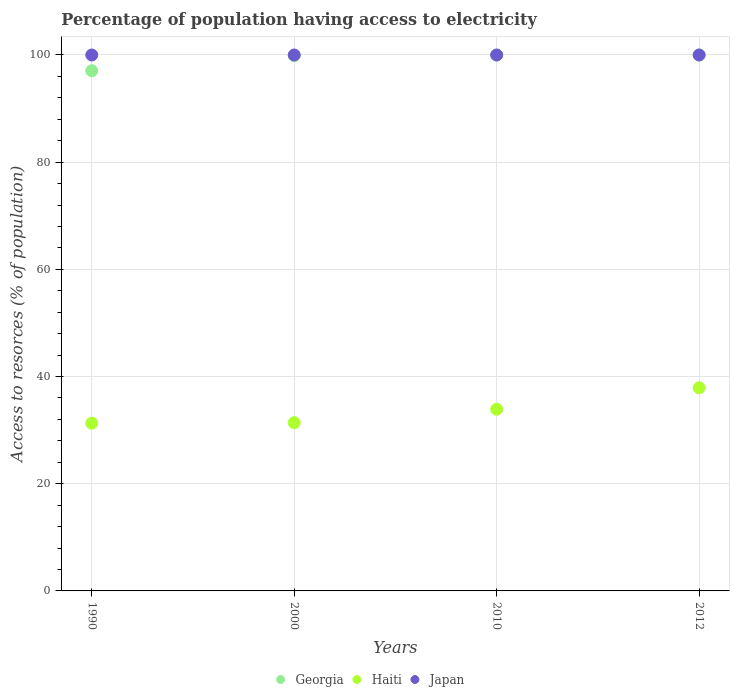How many different coloured dotlines are there?
Keep it short and to the point. 3. Is the number of dotlines equal to the number of legend labels?
Provide a succinct answer. Yes. What is the percentage of population having access to electricity in Georgia in 2010?
Offer a very short reply. 100. Across all years, what is the maximum percentage of population having access to electricity in Haiti?
Keep it short and to the point. 37.9. Across all years, what is the minimum percentage of population having access to electricity in Japan?
Offer a terse response. 100. In which year was the percentage of population having access to electricity in Japan maximum?
Offer a terse response. 1990. In which year was the percentage of population having access to electricity in Georgia minimum?
Make the answer very short. 1990. What is the total percentage of population having access to electricity in Japan in the graph?
Your answer should be very brief. 400. What is the difference between the percentage of population having access to electricity in Georgia in 2000 and that in 2012?
Offer a very short reply. -0.1. What is the difference between the percentage of population having access to electricity in Haiti in 1990 and the percentage of population having access to electricity in Japan in 2012?
Make the answer very short. -68.7. What is the average percentage of population having access to electricity in Georgia per year?
Your answer should be very brief. 99.24. In the year 2010, what is the difference between the percentage of population having access to electricity in Japan and percentage of population having access to electricity in Georgia?
Your response must be concise. 0. In how many years, is the percentage of population having access to electricity in Haiti greater than 8 %?
Your answer should be compact. 4. What is the ratio of the percentage of population having access to electricity in Haiti in 1990 to that in 2000?
Offer a very short reply. 1. Is the difference between the percentage of population having access to electricity in Japan in 1990 and 2012 greater than the difference between the percentage of population having access to electricity in Georgia in 1990 and 2012?
Give a very brief answer. Yes. What is the difference between the highest and the lowest percentage of population having access to electricity in Georgia?
Your answer should be very brief. 2.94. Is the sum of the percentage of population having access to electricity in Georgia in 1990 and 2000 greater than the maximum percentage of population having access to electricity in Japan across all years?
Give a very brief answer. Yes. Does the percentage of population having access to electricity in Japan monotonically increase over the years?
Provide a short and direct response. No. Is the percentage of population having access to electricity in Haiti strictly less than the percentage of population having access to electricity in Georgia over the years?
Make the answer very short. Yes. How many dotlines are there?
Your answer should be very brief. 3. How many years are there in the graph?
Offer a terse response. 4. What is the difference between two consecutive major ticks on the Y-axis?
Your answer should be very brief. 20. Are the values on the major ticks of Y-axis written in scientific E-notation?
Keep it short and to the point. No. Does the graph contain any zero values?
Make the answer very short. No. Does the graph contain grids?
Make the answer very short. Yes. How many legend labels are there?
Provide a short and direct response. 3. What is the title of the graph?
Provide a succinct answer. Percentage of population having access to electricity. What is the label or title of the X-axis?
Keep it short and to the point. Years. What is the label or title of the Y-axis?
Give a very brief answer. Access to resorces (% of population). What is the Access to resorces (% of population) of Georgia in 1990?
Your response must be concise. 97.06. What is the Access to resorces (% of population) of Haiti in 1990?
Ensure brevity in your answer.  31.3. What is the Access to resorces (% of population) in Japan in 1990?
Offer a terse response. 100. What is the Access to resorces (% of population) of Georgia in 2000?
Offer a very short reply. 99.9. What is the Access to resorces (% of population) of Haiti in 2000?
Your answer should be very brief. 31.4. What is the Access to resorces (% of population) of Georgia in 2010?
Offer a very short reply. 100. What is the Access to resorces (% of population) in Haiti in 2010?
Your answer should be very brief. 33.9. What is the Access to resorces (% of population) of Haiti in 2012?
Offer a terse response. 37.9. What is the Access to resorces (% of population) in Japan in 2012?
Provide a short and direct response. 100. Across all years, what is the maximum Access to resorces (% of population) in Haiti?
Provide a succinct answer. 37.9. Across all years, what is the maximum Access to resorces (% of population) in Japan?
Keep it short and to the point. 100. Across all years, what is the minimum Access to resorces (% of population) of Georgia?
Offer a terse response. 97.06. Across all years, what is the minimum Access to resorces (% of population) of Haiti?
Your response must be concise. 31.3. What is the total Access to resorces (% of population) of Georgia in the graph?
Offer a terse response. 396.96. What is the total Access to resorces (% of population) in Haiti in the graph?
Offer a very short reply. 134.5. What is the difference between the Access to resorces (% of population) of Georgia in 1990 and that in 2000?
Make the answer very short. -2.84. What is the difference between the Access to resorces (% of population) of Haiti in 1990 and that in 2000?
Your answer should be compact. -0.1. What is the difference between the Access to resorces (% of population) of Georgia in 1990 and that in 2010?
Offer a terse response. -2.94. What is the difference between the Access to resorces (% of population) of Haiti in 1990 and that in 2010?
Your answer should be very brief. -2.6. What is the difference between the Access to resorces (% of population) of Japan in 1990 and that in 2010?
Provide a succinct answer. 0. What is the difference between the Access to resorces (% of population) of Georgia in 1990 and that in 2012?
Your answer should be compact. -2.94. What is the difference between the Access to resorces (% of population) in Georgia in 2000 and that in 2010?
Your answer should be compact. -0.1. What is the difference between the Access to resorces (% of population) in Haiti in 2000 and that in 2010?
Provide a short and direct response. -2.5. What is the difference between the Access to resorces (% of population) of Georgia in 2000 and that in 2012?
Your answer should be very brief. -0.1. What is the difference between the Access to resorces (% of population) of Japan in 2000 and that in 2012?
Offer a terse response. 0. What is the difference between the Access to resorces (% of population) of Haiti in 2010 and that in 2012?
Make the answer very short. -4. What is the difference between the Access to resorces (% of population) in Japan in 2010 and that in 2012?
Offer a very short reply. 0. What is the difference between the Access to resorces (% of population) in Georgia in 1990 and the Access to resorces (% of population) in Haiti in 2000?
Offer a very short reply. 65.66. What is the difference between the Access to resorces (% of population) of Georgia in 1990 and the Access to resorces (% of population) of Japan in 2000?
Your response must be concise. -2.94. What is the difference between the Access to resorces (% of population) of Haiti in 1990 and the Access to resorces (% of population) of Japan in 2000?
Make the answer very short. -68.7. What is the difference between the Access to resorces (% of population) of Georgia in 1990 and the Access to resorces (% of population) of Haiti in 2010?
Make the answer very short. 63.16. What is the difference between the Access to resorces (% of population) of Georgia in 1990 and the Access to resorces (% of population) of Japan in 2010?
Give a very brief answer. -2.94. What is the difference between the Access to resorces (% of population) in Haiti in 1990 and the Access to resorces (% of population) in Japan in 2010?
Your answer should be compact. -68.7. What is the difference between the Access to resorces (% of population) of Georgia in 1990 and the Access to resorces (% of population) of Haiti in 2012?
Give a very brief answer. 59.16. What is the difference between the Access to resorces (% of population) in Georgia in 1990 and the Access to resorces (% of population) in Japan in 2012?
Your response must be concise. -2.94. What is the difference between the Access to resorces (% of population) of Haiti in 1990 and the Access to resorces (% of population) of Japan in 2012?
Offer a very short reply. -68.7. What is the difference between the Access to resorces (% of population) of Georgia in 2000 and the Access to resorces (% of population) of Haiti in 2010?
Your answer should be very brief. 66. What is the difference between the Access to resorces (% of population) of Haiti in 2000 and the Access to resorces (% of population) of Japan in 2010?
Give a very brief answer. -68.6. What is the difference between the Access to resorces (% of population) in Georgia in 2000 and the Access to resorces (% of population) in Haiti in 2012?
Offer a very short reply. 62. What is the difference between the Access to resorces (% of population) in Haiti in 2000 and the Access to resorces (% of population) in Japan in 2012?
Ensure brevity in your answer.  -68.6. What is the difference between the Access to resorces (% of population) in Georgia in 2010 and the Access to resorces (% of population) in Haiti in 2012?
Offer a terse response. 62.1. What is the difference between the Access to resorces (% of population) of Haiti in 2010 and the Access to resorces (% of population) of Japan in 2012?
Ensure brevity in your answer.  -66.1. What is the average Access to resorces (% of population) of Georgia per year?
Your answer should be very brief. 99.24. What is the average Access to resorces (% of population) in Haiti per year?
Keep it short and to the point. 33.62. In the year 1990, what is the difference between the Access to resorces (% of population) of Georgia and Access to resorces (% of population) of Haiti?
Your response must be concise. 65.76. In the year 1990, what is the difference between the Access to resorces (% of population) of Georgia and Access to resorces (% of population) of Japan?
Provide a short and direct response. -2.94. In the year 1990, what is the difference between the Access to resorces (% of population) in Haiti and Access to resorces (% of population) in Japan?
Give a very brief answer. -68.7. In the year 2000, what is the difference between the Access to resorces (% of population) of Georgia and Access to resorces (% of population) of Haiti?
Provide a succinct answer. 68.5. In the year 2000, what is the difference between the Access to resorces (% of population) of Haiti and Access to resorces (% of population) of Japan?
Your response must be concise. -68.6. In the year 2010, what is the difference between the Access to resorces (% of population) in Georgia and Access to resorces (% of population) in Haiti?
Your response must be concise. 66.1. In the year 2010, what is the difference between the Access to resorces (% of population) in Haiti and Access to resorces (% of population) in Japan?
Your answer should be compact. -66.1. In the year 2012, what is the difference between the Access to resorces (% of population) in Georgia and Access to resorces (% of population) in Haiti?
Ensure brevity in your answer.  62.1. In the year 2012, what is the difference between the Access to resorces (% of population) of Haiti and Access to resorces (% of population) of Japan?
Provide a succinct answer. -62.1. What is the ratio of the Access to resorces (% of population) of Georgia in 1990 to that in 2000?
Offer a terse response. 0.97. What is the ratio of the Access to resorces (% of population) in Haiti in 1990 to that in 2000?
Provide a short and direct response. 1. What is the ratio of the Access to resorces (% of population) of Georgia in 1990 to that in 2010?
Keep it short and to the point. 0.97. What is the ratio of the Access to resorces (% of population) in Haiti in 1990 to that in 2010?
Make the answer very short. 0.92. What is the ratio of the Access to resorces (% of population) of Japan in 1990 to that in 2010?
Ensure brevity in your answer.  1. What is the ratio of the Access to resorces (% of population) of Georgia in 1990 to that in 2012?
Make the answer very short. 0.97. What is the ratio of the Access to resorces (% of population) in Haiti in 1990 to that in 2012?
Make the answer very short. 0.83. What is the ratio of the Access to resorces (% of population) of Japan in 1990 to that in 2012?
Offer a very short reply. 1. What is the ratio of the Access to resorces (% of population) of Haiti in 2000 to that in 2010?
Your answer should be compact. 0.93. What is the ratio of the Access to resorces (% of population) of Haiti in 2000 to that in 2012?
Provide a succinct answer. 0.83. What is the ratio of the Access to resorces (% of population) in Haiti in 2010 to that in 2012?
Provide a short and direct response. 0.89. What is the difference between the highest and the second highest Access to resorces (% of population) in Haiti?
Your answer should be compact. 4. What is the difference between the highest and the lowest Access to resorces (% of population) in Georgia?
Provide a short and direct response. 2.94. What is the difference between the highest and the lowest Access to resorces (% of population) of Haiti?
Provide a short and direct response. 6.6. 